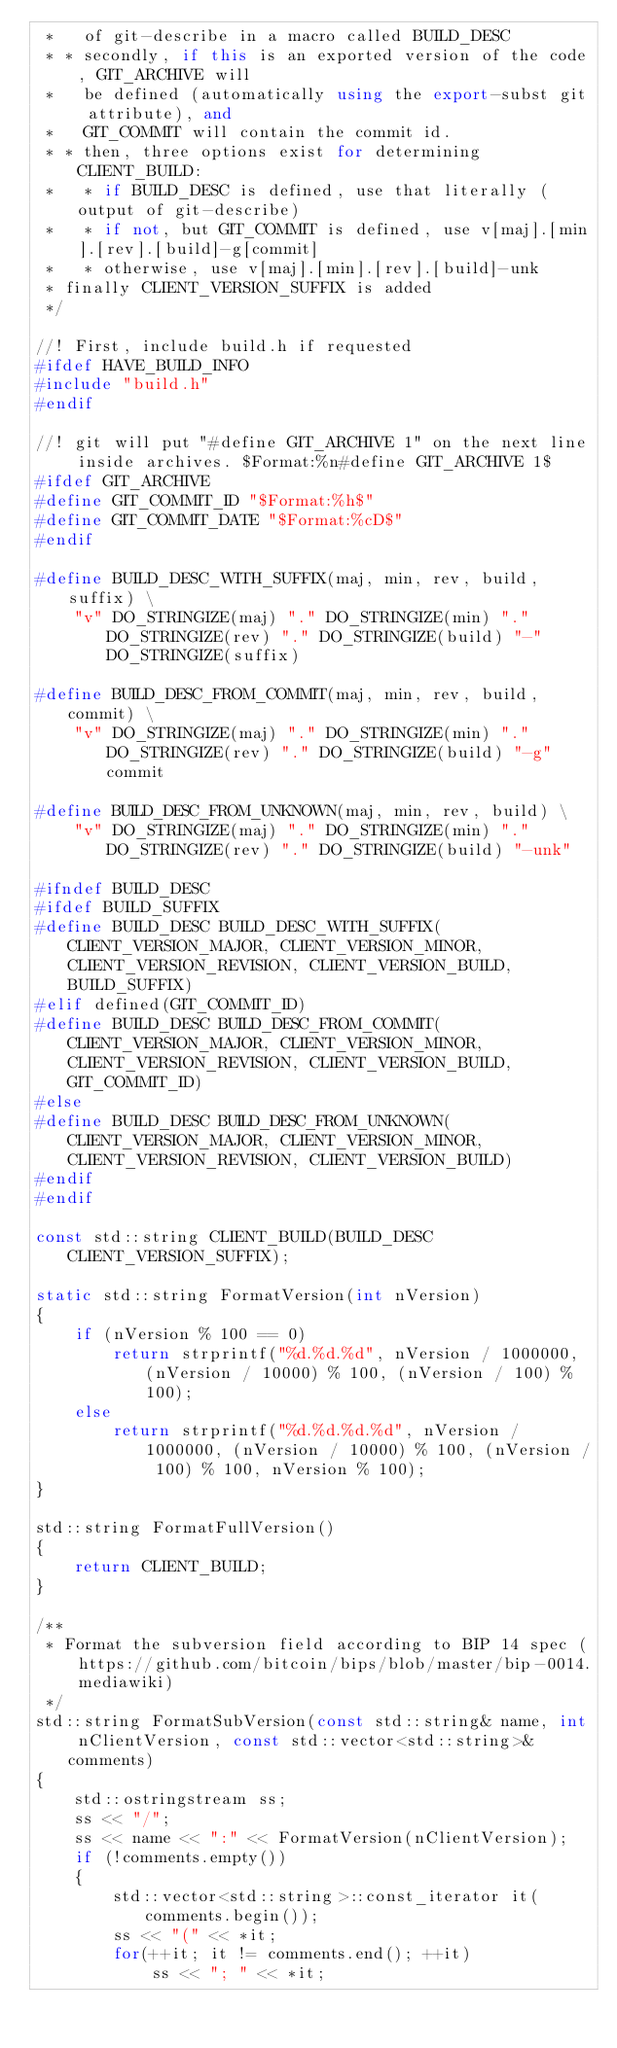<code> <loc_0><loc_0><loc_500><loc_500><_C++_> *   of git-describe in a macro called BUILD_DESC
 * * secondly, if this is an exported version of the code, GIT_ARCHIVE will
 *   be defined (automatically using the export-subst git attribute), and
 *   GIT_COMMIT will contain the commit id.
 * * then, three options exist for determining CLIENT_BUILD:
 *   * if BUILD_DESC is defined, use that literally (output of git-describe)
 *   * if not, but GIT_COMMIT is defined, use v[maj].[min].[rev].[build]-g[commit]
 *   * otherwise, use v[maj].[min].[rev].[build]-unk
 * finally CLIENT_VERSION_SUFFIX is added
 */

//! First, include build.h if requested
#ifdef HAVE_BUILD_INFO
#include "build.h"
#endif

//! git will put "#define GIT_ARCHIVE 1" on the next line inside archives. $Format:%n#define GIT_ARCHIVE 1$
#ifdef GIT_ARCHIVE
#define GIT_COMMIT_ID "$Format:%h$"
#define GIT_COMMIT_DATE "$Format:%cD$"
#endif

#define BUILD_DESC_WITH_SUFFIX(maj, min, rev, build, suffix) \
    "v" DO_STRINGIZE(maj) "." DO_STRINGIZE(min) "." DO_STRINGIZE(rev) "." DO_STRINGIZE(build) "-" DO_STRINGIZE(suffix)

#define BUILD_DESC_FROM_COMMIT(maj, min, rev, build, commit) \
    "v" DO_STRINGIZE(maj) "." DO_STRINGIZE(min) "." DO_STRINGIZE(rev) "." DO_STRINGIZE(build) "-g" commit

#define BUILD_DESC_FROM_UNKNOWN(maj, min, rev, build) \
    "v" DO_STRINGIZE(maj) "." DO_STRINGIZE(min) "." DO_STRINGIZE(rev) "." DO_STRINGIZE(build) "-unk"

#ifndef BUILD_DESC
#ifdef BUILD_SUFFIX
#define BUILD_DESC BUILD_DESC_WITH_SUFFIX(CLIENT_VERSION_MAJOR, CLIENT_VERSION_MINOR, CLIENT_VERSION_REVISION, CLIENT_VERSION_BUILD, BUILD_SUFFIX)
#elif defined(GIT_COMMIT_ID)
#define BUILD_DESC BUILD_DESC_FROM_COMMIT(CLIENT_VERSION_MAJOR, CLIENT_VERSION_MINOR, CLIENT_VERSION_REVISION, CLIENT_VERSION_BUILD, GIT_COMMIT_ID)
#else
#define BUILD_DESC BUILD_DESC_FROM_UNKNOWN(CLIENT_VERSION_MAJOR, CLIENT_VERSION_MINOR, CLIENT_VERSION_REVISION, CLIENT_VERSION_BUILD)
#endif
#endif

const std::string CLIENT_BUILD(BUILD_DESC CLIENT_VERSION_SUFFIX);

static std::string FormatVersion(int nVersion)
{
    if (nVersion % 100 == 0)
        return strprintf("%d.%d.%d", nVersion / 1000000, (nVersion / 10000) % 100, (nVersion / 100) % 100);
    else
        return strprintf("%d.%d.%d.%d", nVersion / 1000000, (nVersion / 10000) % 100, (nVersion / 100) % 100, nVersion % 100);
}

std::string FormatFullVersion()
{
    return CLIENT_BUILD;
}

/**
 * Format the subversion field according to BIP 14 spec (https://github.com/bitcoin/bips/blob/master/bip-0014.mediawiki)
 */
std::string FormatSubVersion(const std::string& name, int nClientVersion, const std::vector<std::string>& comments)
{
    std::ostringstream ss;
    ss << "/";
    ss << name << ":" << FormatVersion(nClientVersion);
    if (!comments.empty())
    {
        std::vector<std::string>::const_iterator it(comments.begin());
        ss << "(" << *it;
        for(++it; it != comments.end(); ++it)
            ss << "; " << *it;</code> 